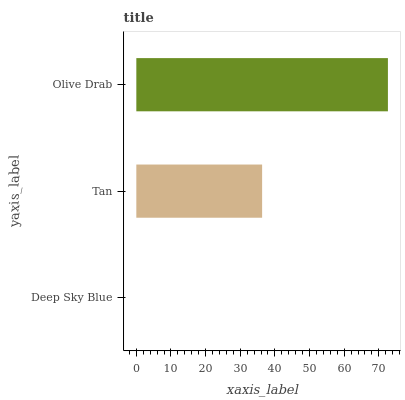Is Deep Sky Blue the minimum?
Answer yes or no. Yes. Is Olive Drab the maximum?
Answer yes or no. Yes. Is Tan the minimum?
Answer yes or no. No. Is Tan the maximum?
Answer yes or no. No. Is Tan greater than Deep Sky Blue?
Answer yes or no. Yes. Is Deep Sky Blue less than Tan?
Answer yes or no. Yes. Is Deep Sky Blue greater than Tan?
Answer yes or no. No. Is Tan less than Deep Sky Blue?
Answer yes or no. No. Is Tan the high median?
Answer yes or no. Yes. Is Tan the low median?
Answer yes or no. Yes. Is Olive Drab the high median?
Answer yes or no. No. Is Olive Drab the low median?
Answer yes or no. No. 